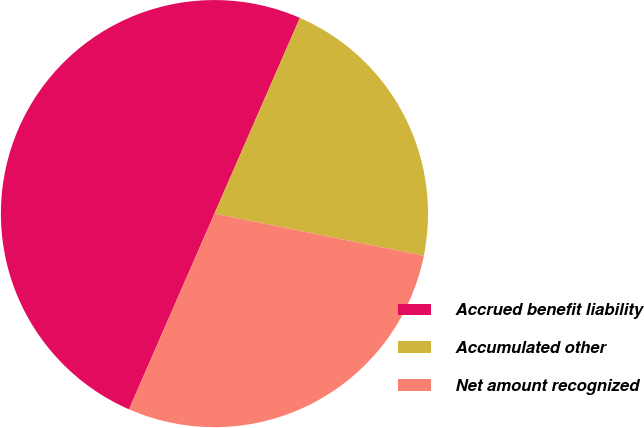Convert chart. <chart><loc_0><loc_0><loc_500><loc_500><pie_chart><fcel>Accrued benefit liability<fcel>Accumulated other<fcel>Net amount recognized<nl><fcel>50.0%<fcel>21.61%<fcel>28.39%<nl></chart> 